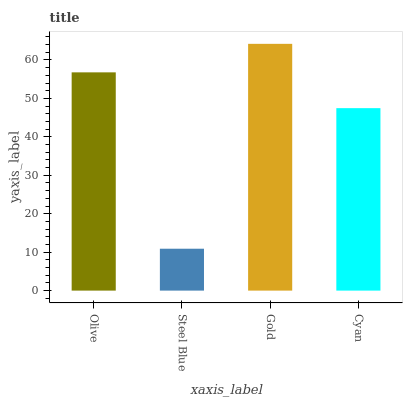Is Steel Blue the minimum?
Answer yes or no. Yes. Is Gold the maximum?
Answer yes or no. Yes. Is Gold the minimum?
Answer yes or no. No. Is Steel Blue the maximum?
Answer yes or no. No. Is Gold greater than Steel Blue?
Answer yes or no. Yes. Is Steel Blue less than Gold?
Answer yes or no. Yes. Is Steel Blue greater than Gold?
Answer yes or no. No. Is Gold less than Steel Blue?
Answer yes or no. No. Is Olive the high median?
Answer yes or no. Yes. Is Cyan the low median?
Answer yes or no. Yes. Is Steel Blue the high median?
Answer yes or no. No. Is Steel Blue the low median?
Answer yes or no. No. 